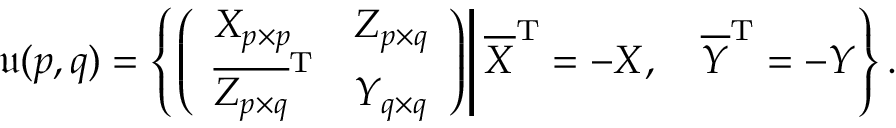<formula> <loc_0><loc_0><loc_500><loc_500>{ \mathfrak { u } } ( p , q ) = \left \{ \left ( { \begin{array} { l l } { X _ { p \times p } } & { Z _ { p \times q } } \\ { { \overline { { Z _ { p \times q } } } } ^ { T } } & { Y _ { q \times q } } \end{array} } \right ) \right | { \overline { X } } ^ { T } = - X , \quad \overline { Y } ^ { T } = - Y \right \} .</formula> 